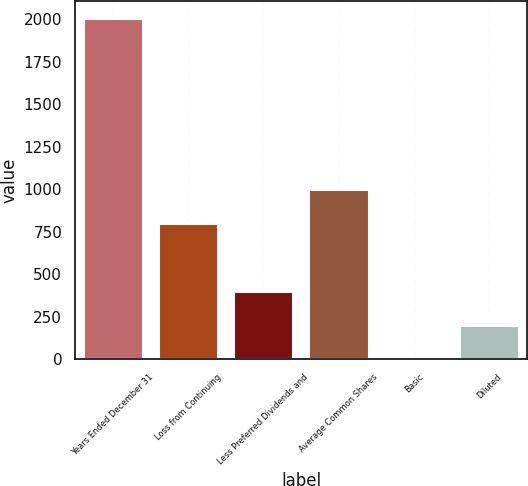Convert chart to OTSL. <chart><loc_0><loc_0><loc_500><loc_500><bar_chart><fcel>Years Ended December 31<fcel>Loss from Continuing<fcel>Less Preferred Dividends and<fcel>Average Common Shares<fcel>Basic<fcel>Diluted<nl><fcel>2005<fcel>802.43<fcel>401.57<fcel>1002.86<fcel>0.71<fcel>201.14<nl></chart> 